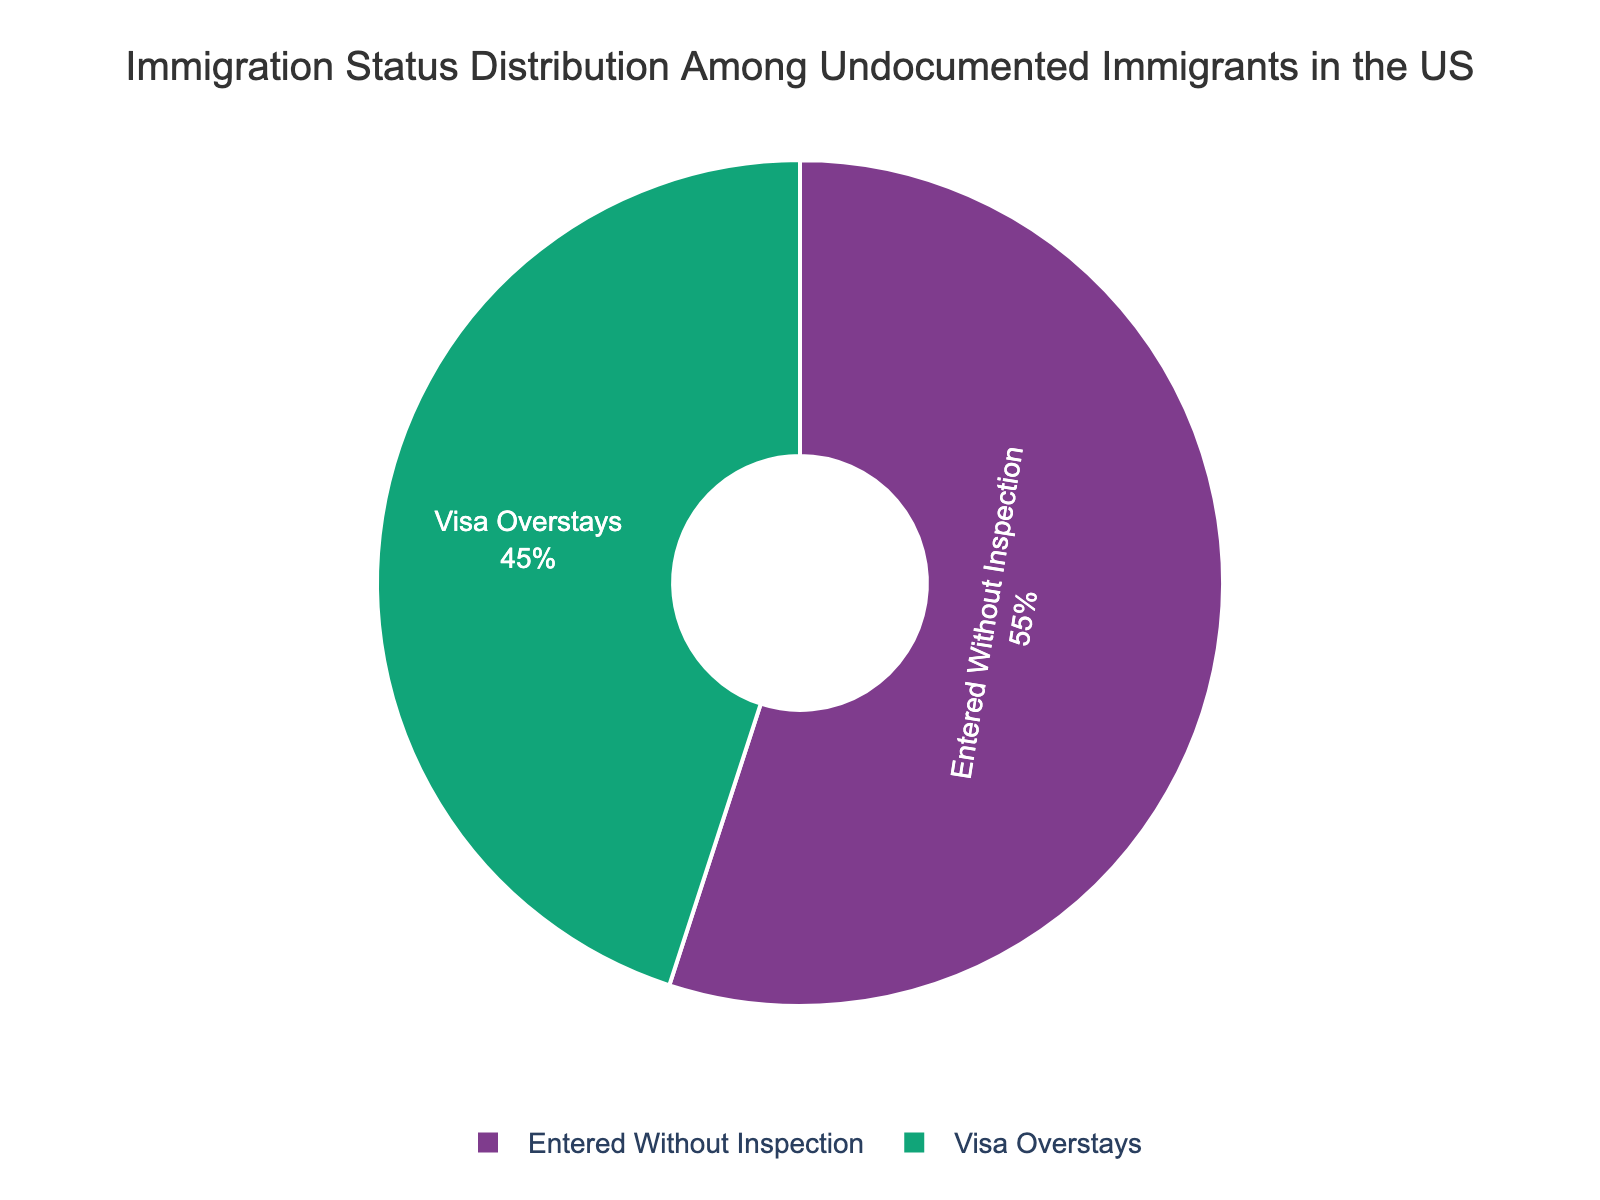What percentage of undocumented immigrants in the US are overstayers? The pie chart shows different immigration statuses. Look for the section labeled "Visa Overstays" and note its percentage.
Answer: 45% What percentage of undocumented immigrants entered without inspection? The pie chart shows different immigration statuses. Look for the section labeled "Entered Without Inspection" and observe its percentage.
Answer: 55% Which immigration status has a greater representation among undocumented immigrants, visa overstayers or those who entered without inspection? Compare the percentages of the two categories shown in the pie chart. "Entered Without Inspection" has 55%, and "Visa Overstays" has 45%.
Answer: Entered Without Inspection What is the difference in percentage between those who overstayed their visas and those who entered without inspection? Subtract the percentage of "Visa Overstays" from "Entered Without Inspection": 55% - 45% = 10%.
Answer: 10% What is the total percentage represented in the pie chart? Sum the percentages of both categories shown: 45% + 55% = 100%.
Answer: 100% If the pie chart was divided into sections with equal representation, what would each section’s percentage be? Divide 100% by the number of sections (2): 100% / 2 = 50%.
Answer: 50% If the visa overstaying rate increases by 5%, what will the new percentage be for visa overstayers? Add 5% to the current percentage of 45%: 45% + 5% = 50%.
Answer: 50% By how many percentage points does the 'Entered Without Inspection' category exceed the 'Visa Overstays' category? Identify the percentage points for both categories and subtract the smaller percentage from the larger one: 55% - 45% = 10 percentage points.
Answer: 10 